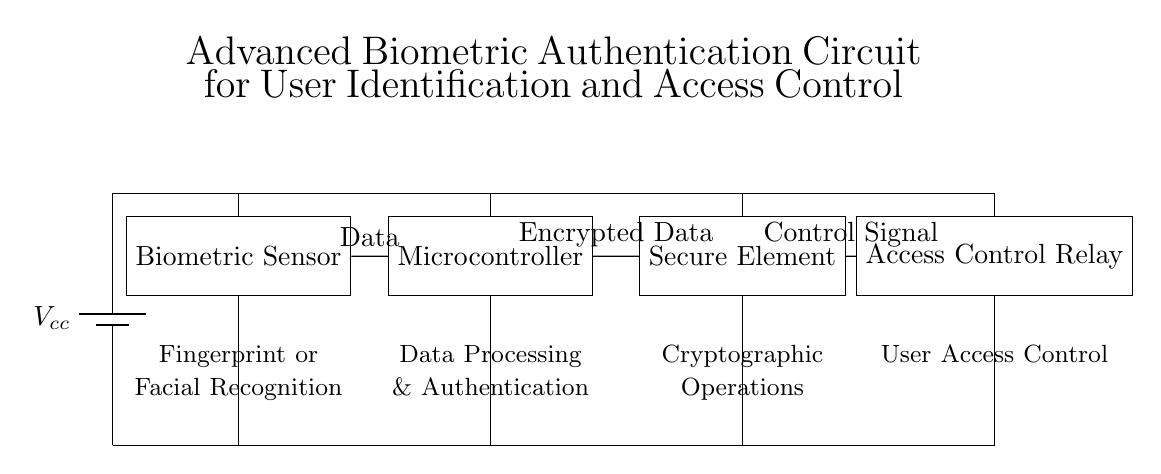What is the main function of the biometric sensor? The main function of the biometric sensor is to capture unique biometric data, such as fingerprints or facial characteristics, for user identification.
Answer: Fingerprint or Facial Recognition What connects the biometric sensor to the microcontroller? The connection between the biometric sensor and the microcontroller is represented by a line labeled "Data," indicating that data is transmitted from the sensor to the microcontroller.
Answer: Data What does the microcontroller process? The microcontroller is responsible for data processing and authentication, handling the raw data received from the biometric sensor and making decisions based on it.
Answer: Data Processing & Authentication What role does the secure element play in this circuit? The secure element performs cryptographic operations, ensuring that the data is protected and securely processed before sending control signals.
Answer: Cryptographic Operations Which component provides the control signal for access? The control signal for access is provided by the access control relay, which acts on the output from the secure element to grant or deny user access.
Answer: Access Control Relay How does the power supply connect to the components? The power supply connects to all components via direct branches, providing the necessary voltage to operate each part of the circuit.
Answer: All components What type of signals are used to communicate between the microcontroller and secure element? The signals used between the microcontroller and secure element are labeled "Encrypted Data," indicating that the data is encrypted during this transmission for security purposes.
Answer: Encrypted Data 